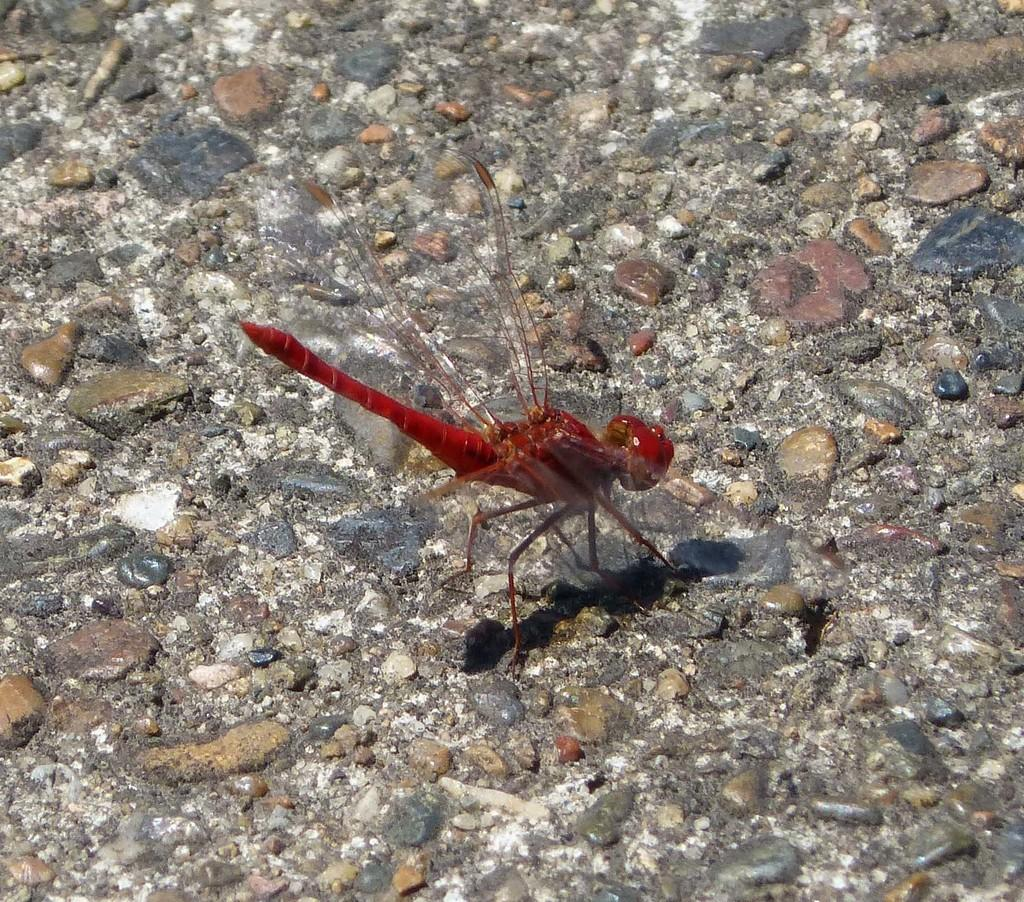What type of creature is present in the image? There is an insect in the image. What color is the insect? The insect is red in color. Where is the insect located in the image? The insect is on the ground. How many girls are holding a chain and a loaf in the image? There are no girls, chains, or loaves present in the image; it features a red insect on the ground. 